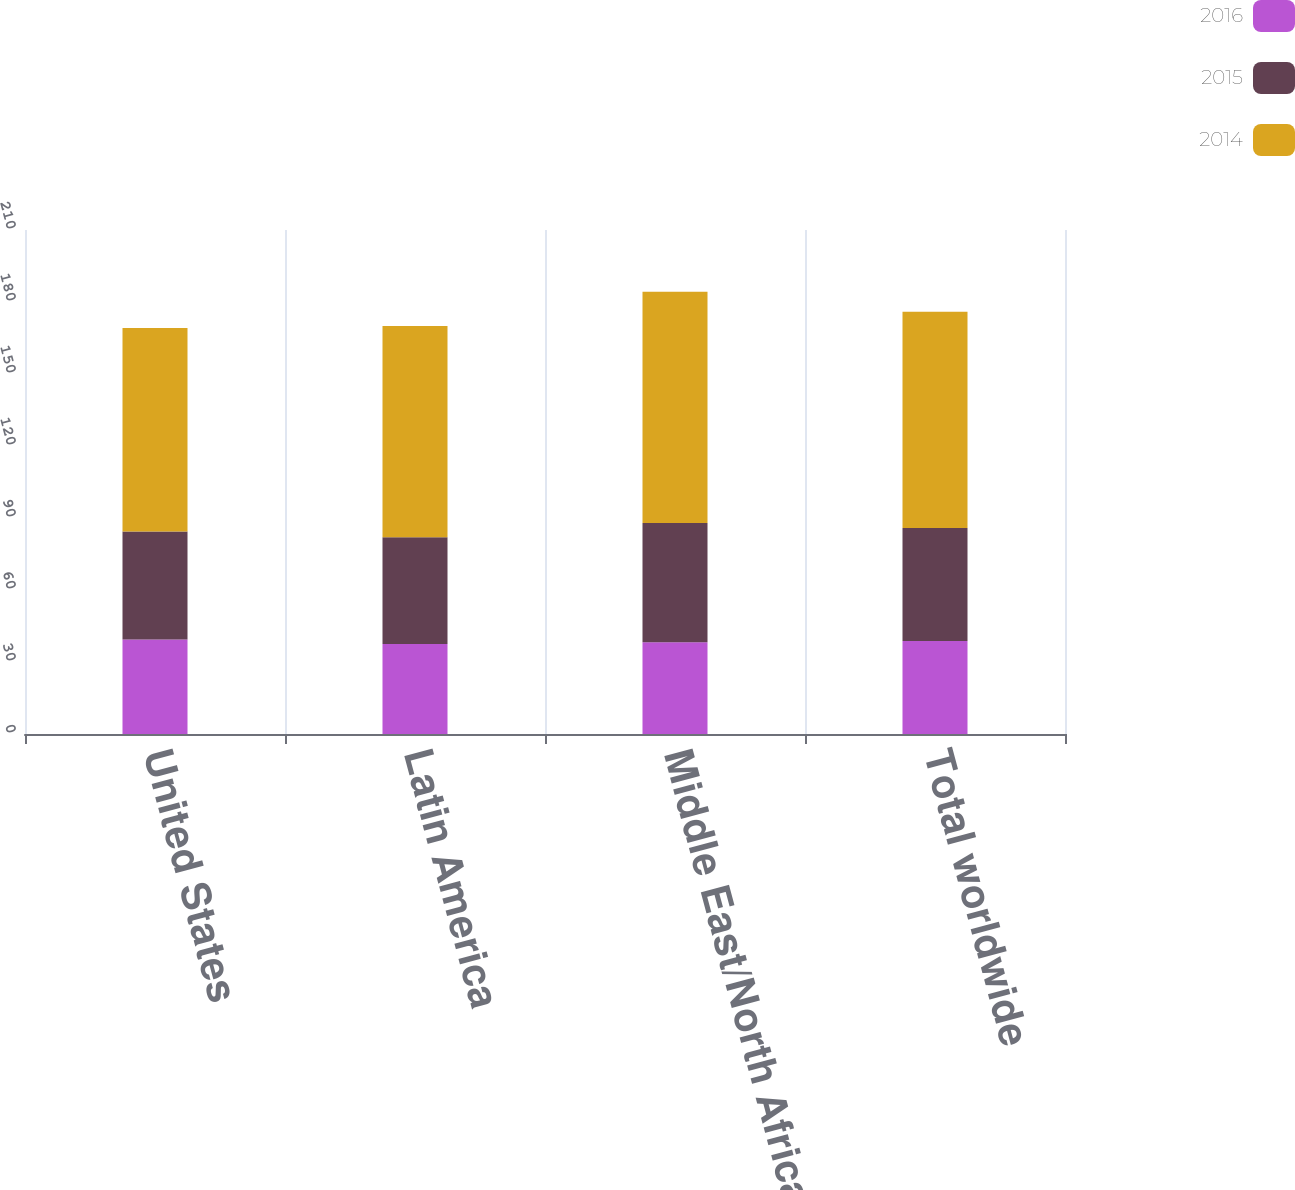Convert chart. <chart><loc_0><loc_0><loc_500><loc_500><stacked_bar_chart><ecel><fcel>United States<fcel>Latin America<fcel>Middle East/North Africa<fcel>Total worldwide<nl><fcel>2016<fcel>39.38<fcel>37.48<fcel>38.25<fcel>38.73<nl><fcel>2015<fcel>45.04<fcel>44.49<fcel>49.65<fcel>47.1<nl><fcel>2014<fcel>84.73<fcel>88<fcel>96.34<fcel>90.13<nl></chart> 